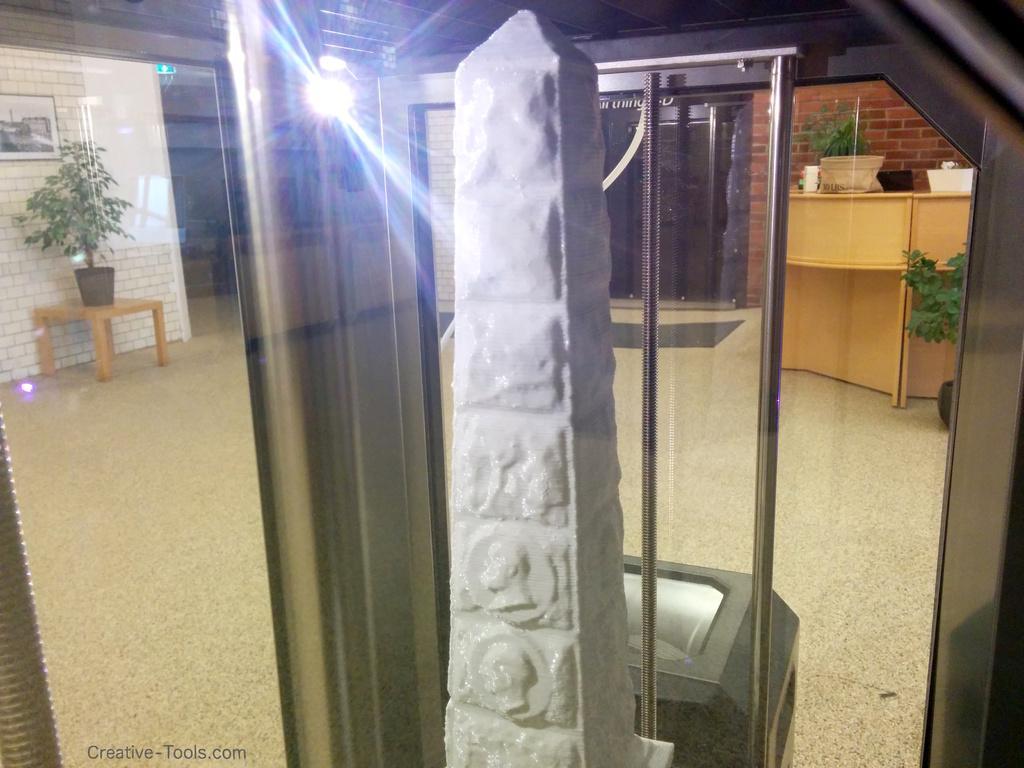How would you summarize this image in a sentence or two? In this image there is a rock having few sculptures, which is kept on a glass box. Right side there is a desk having a bag and few objects on it. Behind there is a plant. Left side there is a table having a pot with a plant. A picture frame is attached to the wall. Behind the glass box there is an object on the floor. 